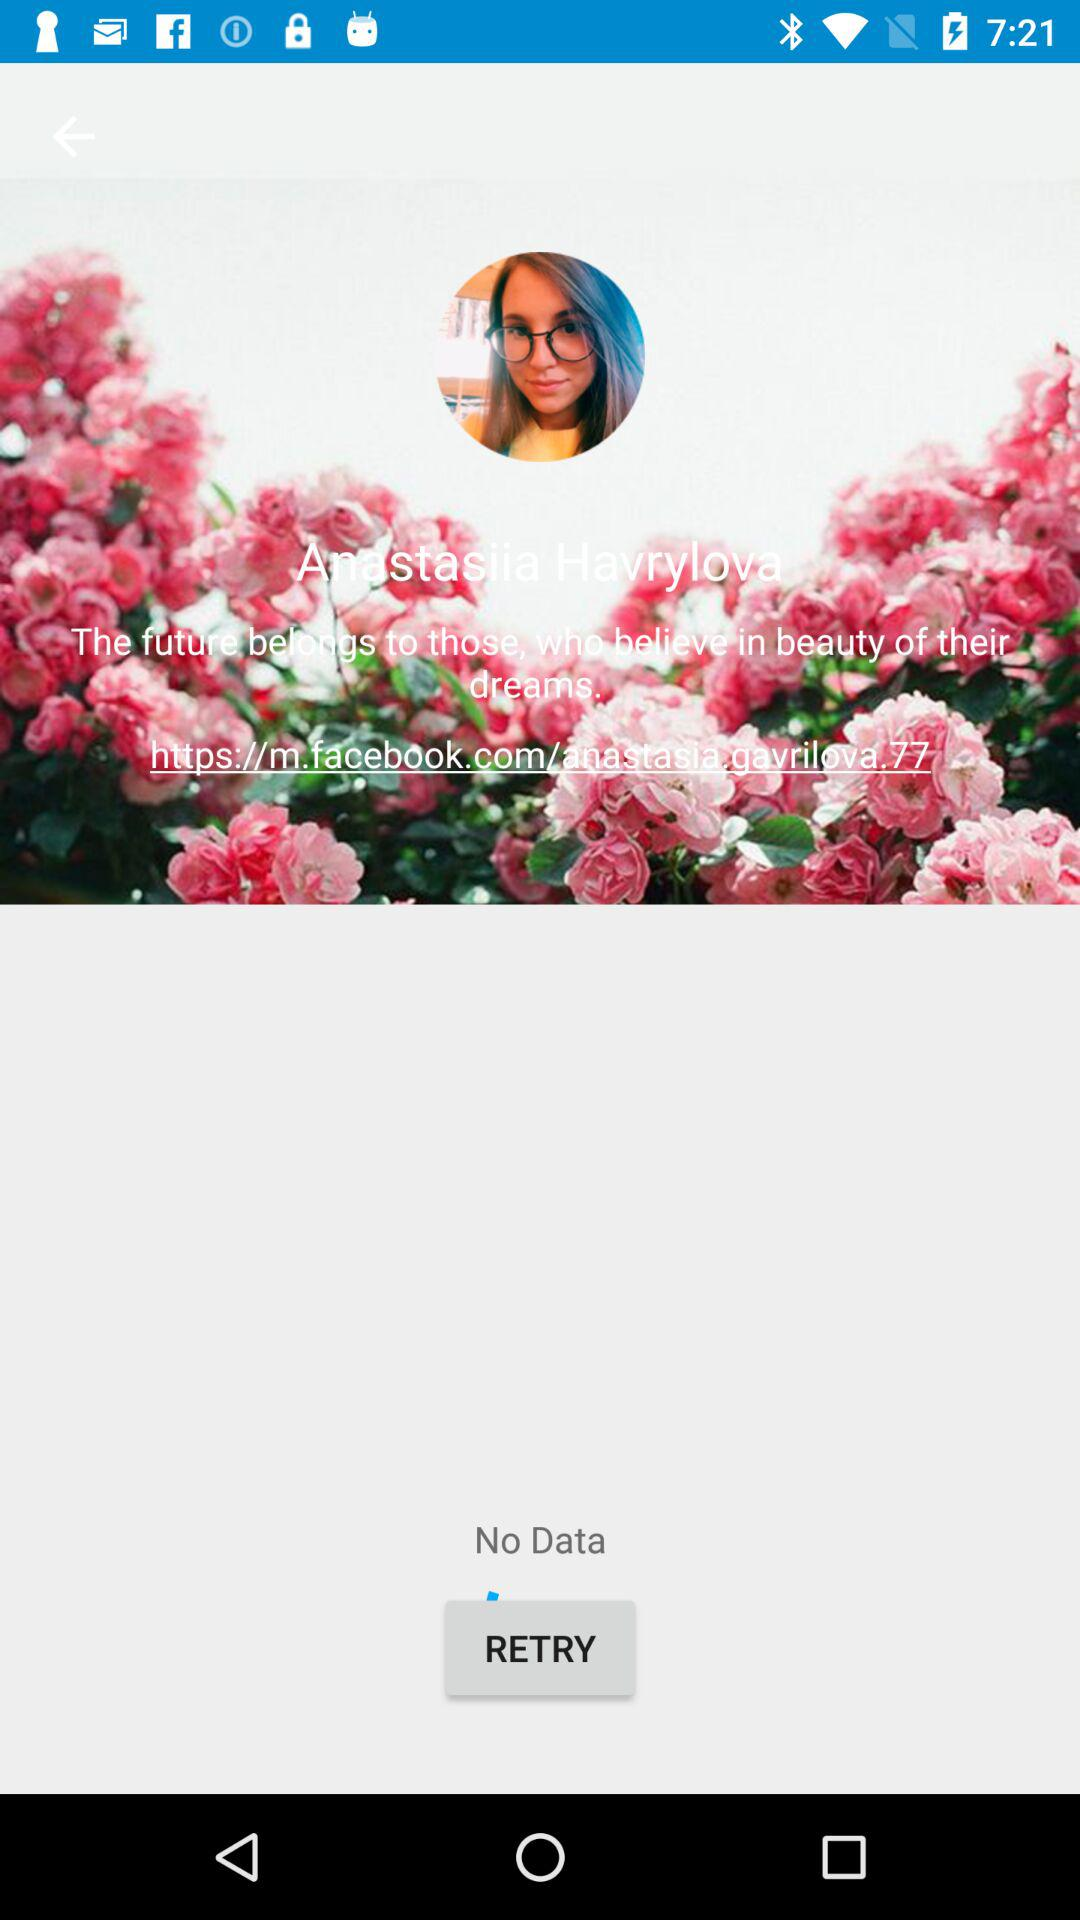What is the username? The username is Anastasiia Havrylova. 